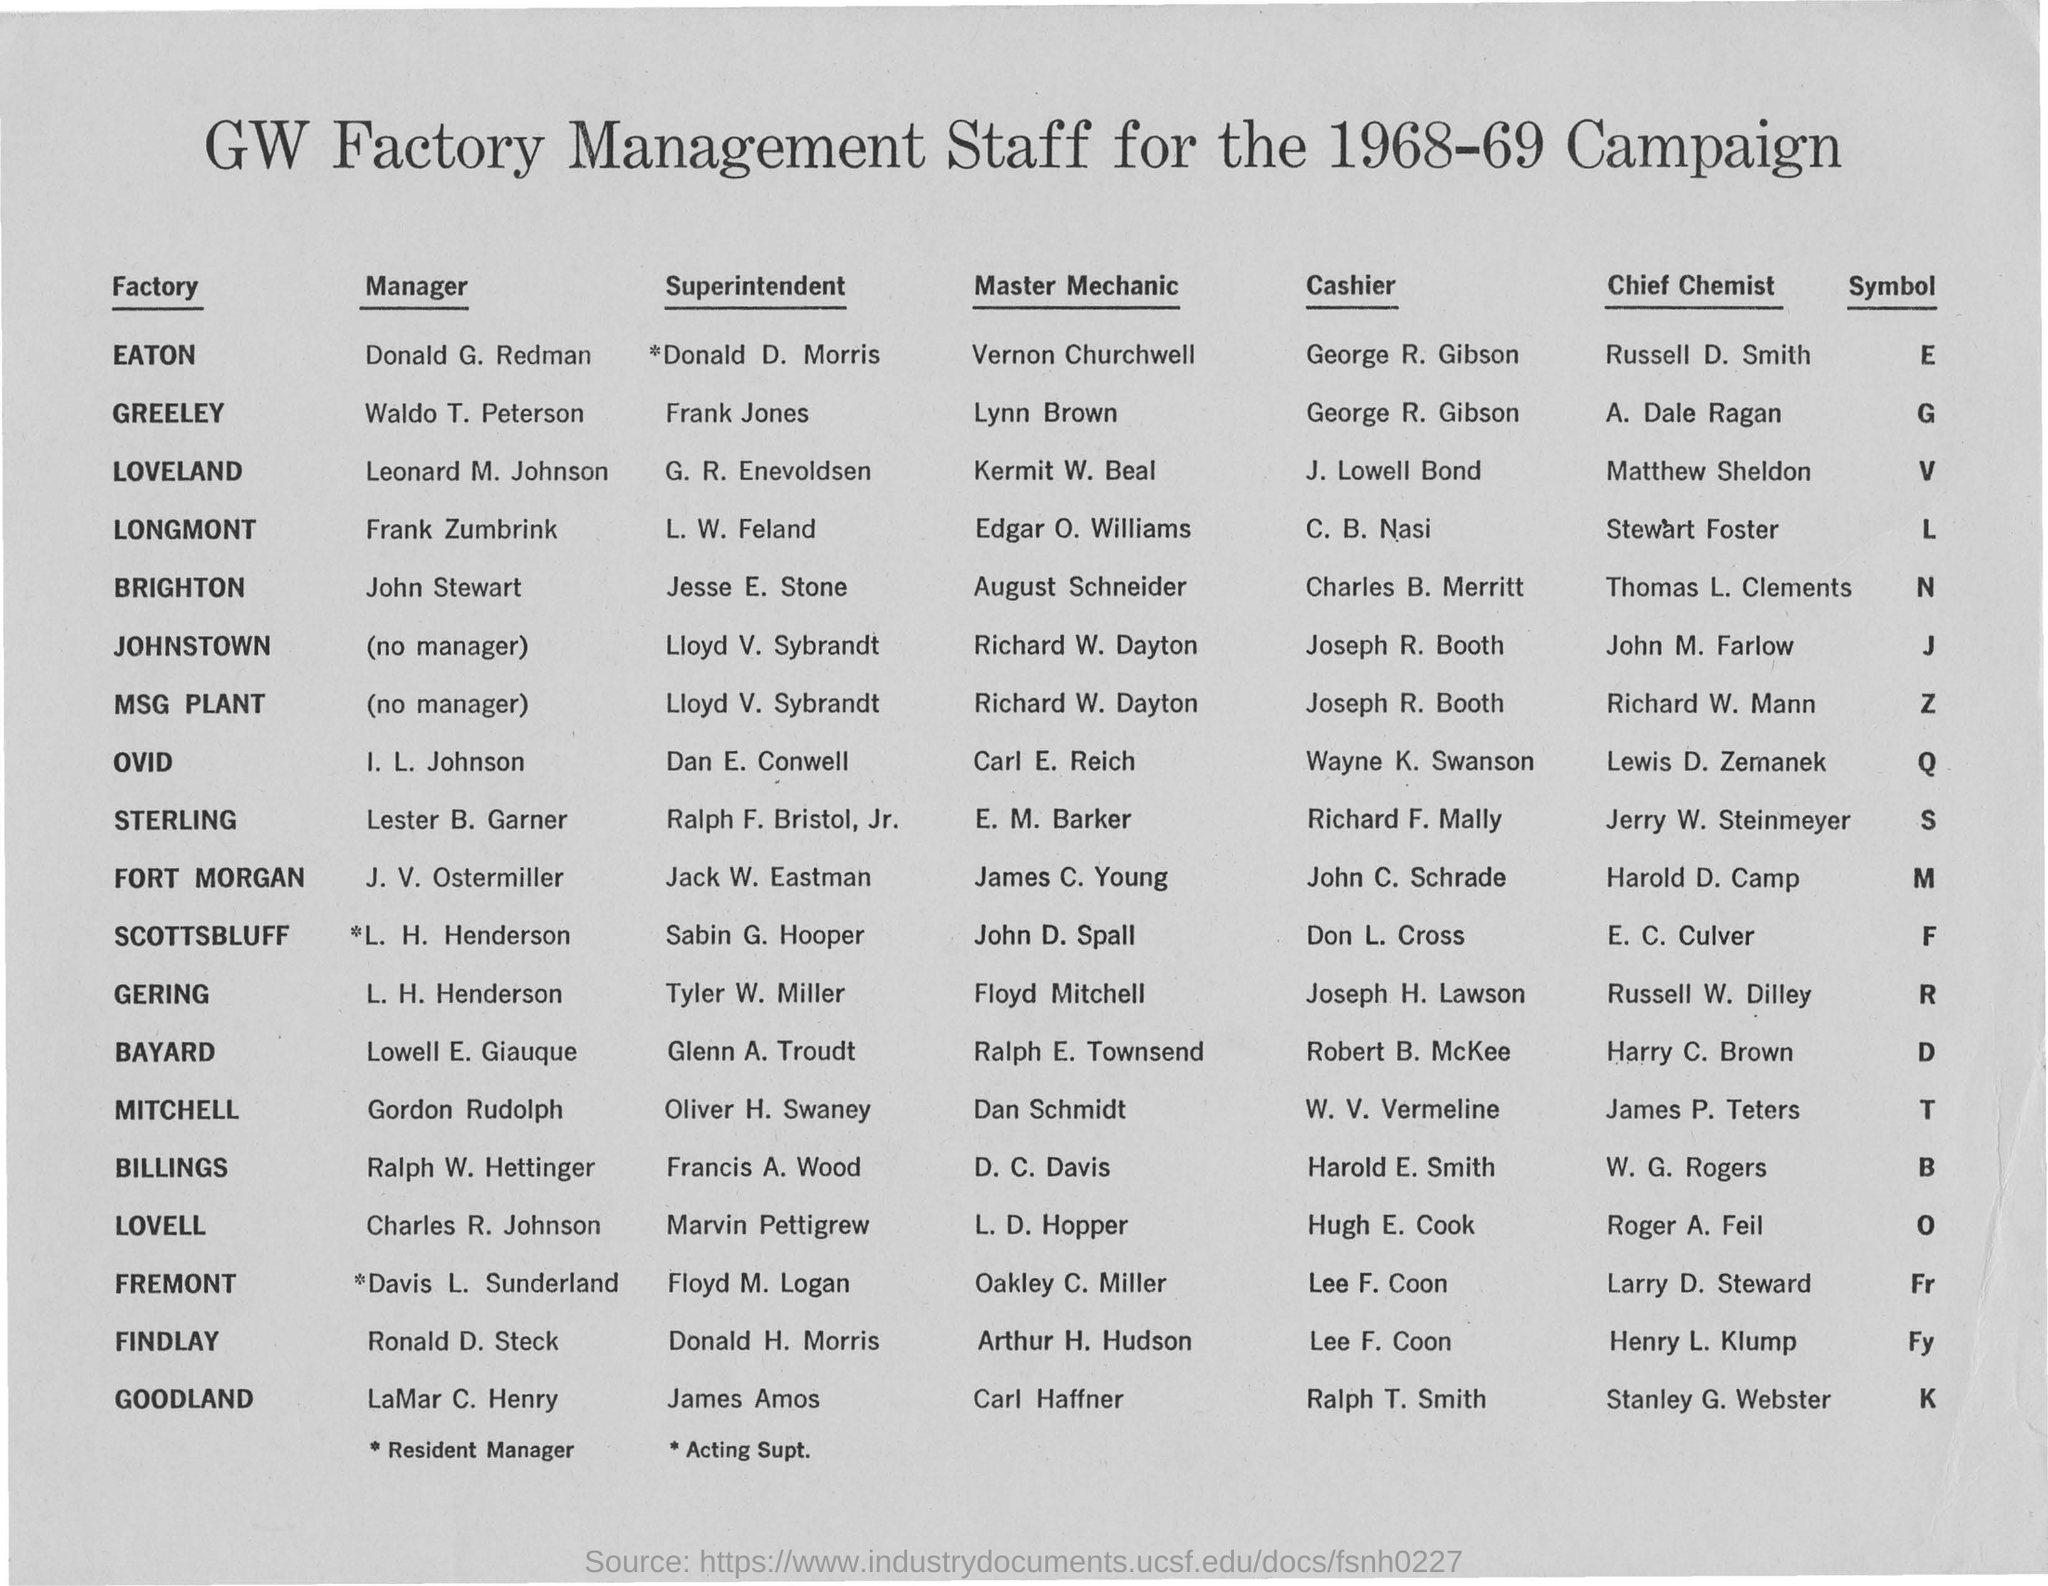What is the heading of the document?
Provide a succinct answer. GW FACTORY MANAGEMENT STAFF FOR THE 1968-69 CAMPAIGN. Who is the Manager of EATON factory?
Make the answer very short. DONALD G. REDMAN. Who is the Master Mechanic of EATON factory?
Offer a very short reply. Vernon Churchwell. What is the Symbol of GOODLAND factory?
Ensure brevity in your answer.  K. 